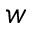<formula> <loc_0><loc_0><loc_500><loc_500>_ { w }</formula> 